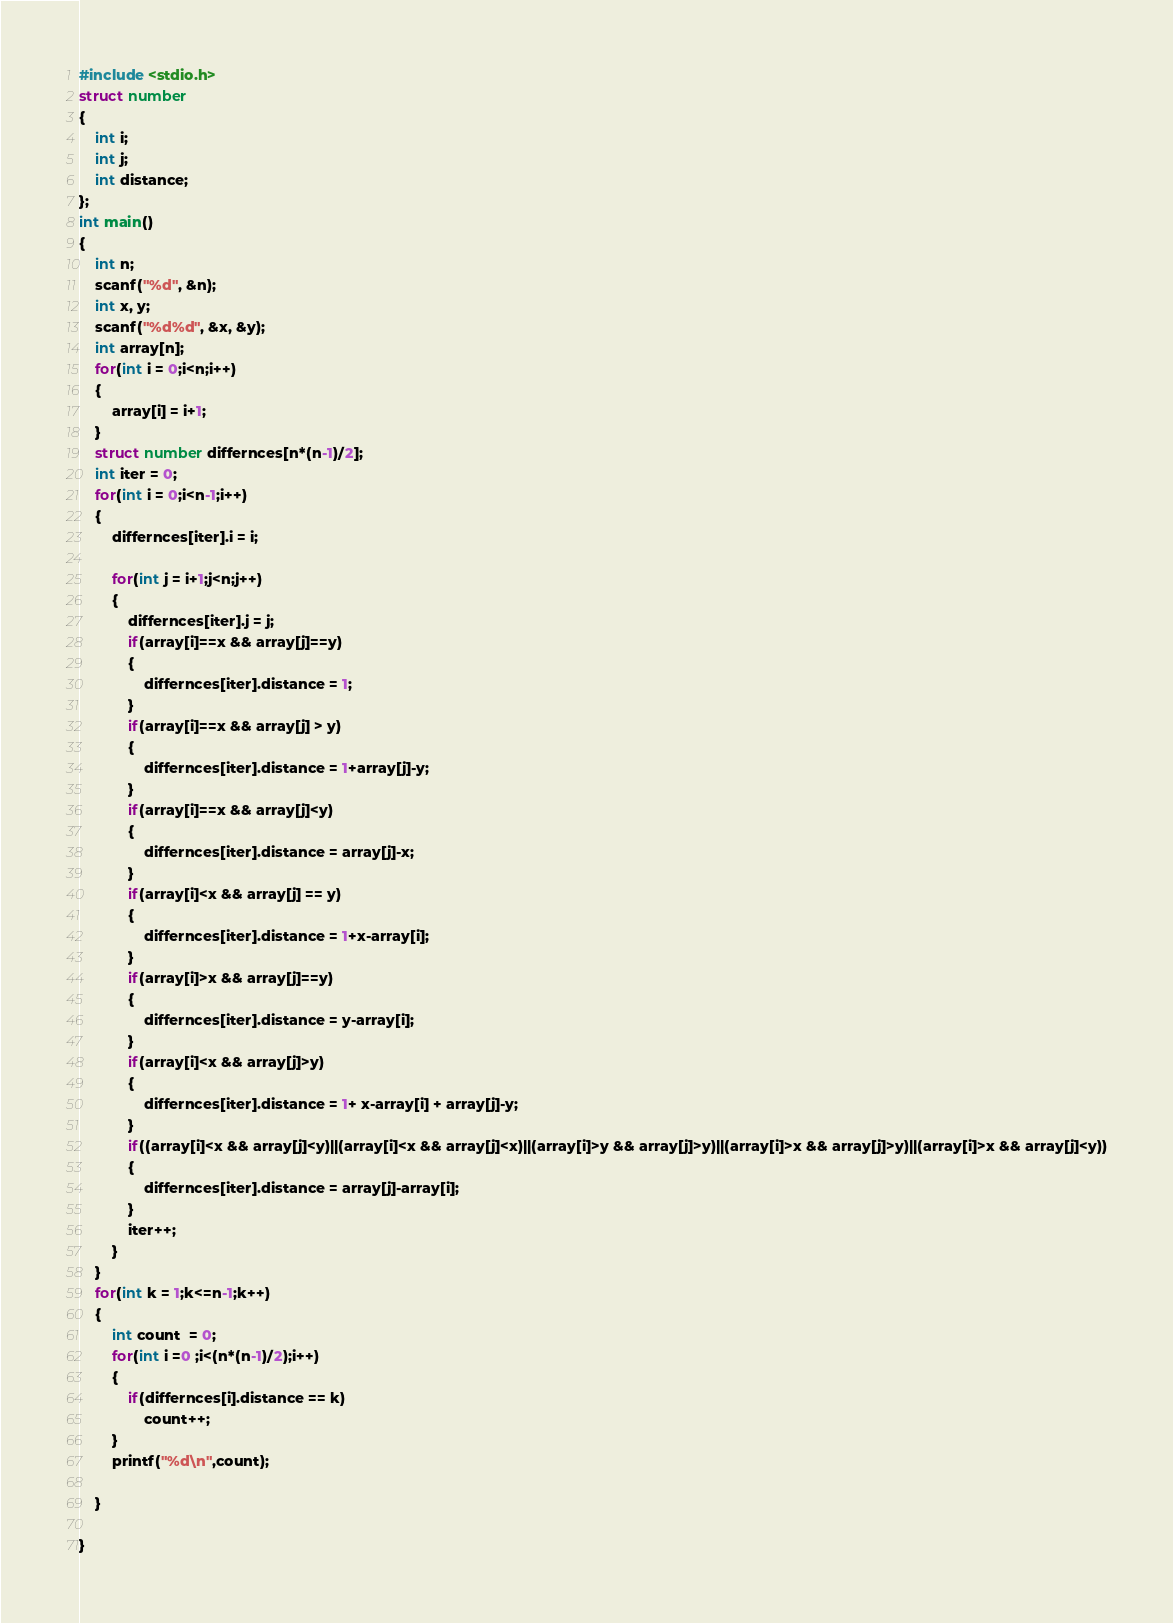<code> <loc_0><loc_0><loc_500><loc_500><_C_>#include <stdio.h>
struct number
{
    int i;
    int j;
    int distance;
};
int main()
{
    int n;
    scanf("%d", &n);
    int x, y;
    scanf("%d%d", &x, &y);
    int array[n];
    for(int i = 0;i<n;i++)
    {
        array[i] = i+1;
    }
    struct number differnces[n*(n-1)/2];
    int iter = 0;
    for(int i = 0;i<n-1;i++)
    {
        differnces[iter].i = i;

        for(int j = i+1;j<n;j++)
        {
            differnces[iter].j = j;
            if(array[i]==x && array[j]==y)
            {
                differnces[iter].distance = 1;
            }
            if(array[i]==x && array[j] > y)
            {
                differnces[iter].distance = 1+array[j]-y;
            }
            if(array[i]==x && array[j]<y)
            {
                differnces[iter].distance = array[j]-x;
            }
            if(array[i]<x && array[j] == y)
            {
                differnces[iter].distance = 1+x-array[i];
            }
            if(array[i]>x && array[j]==y)
            {
                differnces[iter].distance = y-array[i];
            }
            if(array[i]<x && array[j]>y)
            {
                differnces[iter].distance = 1+ x-array[i] + array[j]-y;
            } 
            if((array[i]<x && array[j]<y)||(array[i]<x && array[j]<x)||(array[i]>y && array[j]>y)||(array[i]>x && array[j]>y)||(array[i]>x && array[j]<y))
            {
                differnces[iter].distance = array[j]-array[i];
            }
            iter++;
        }
    }
    for(int k = 1;k<=n-1;k++)
    {
        int count  = 0;
        for(int i =0 ;i<(n*(n-1)/2);i++)
        {
            if(differnces[i].distance == k)
                count++;
        }
        printf("%d\n",count);
        
    }

}</code> 